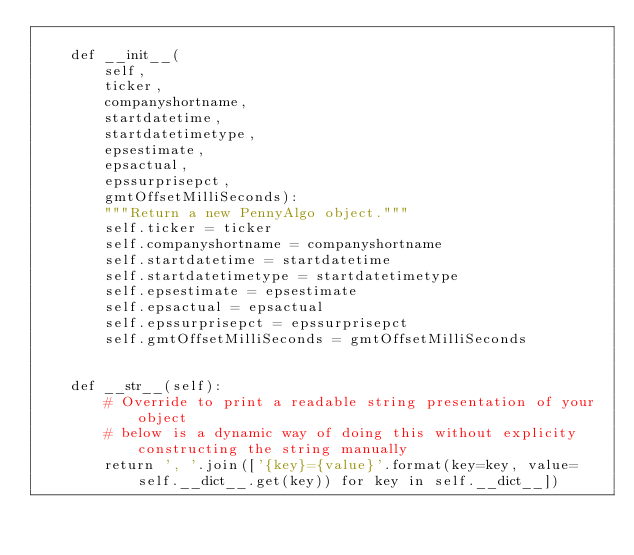<code> <loc_0><loc_0><loc_500><loc_500><_Python_>    
    def __init__(
        self, 
        ticker, 
        companyshortname, 
        startdatetime, 
        startdatetimetype,
        epsestimate,
        epsactual,
        epssurprisepct,
        gmtOffsetMilliSeconds):
        """Return a new PennyAlgo object."""
        self.ticker = ticker
        self.companyshortname = companyshortname
        self.startdatetime = startdatetime
        self.startdatetimetype = startdatetimetype
        self.epsestimate = epsestimate
        self.epsactual = epsactual
        self.epssurprisepct = epssurprisepct
        self.gmtOffsetMilliSeconds = gmtOffsetMilliSeconds


    def __str__(self):
        # Override to print a readable string presentation of your object
        # below is a dynamic way of doing this without explicity constructing the string manually
        return ', '.join(['{key}={value}'.format(key=key, value=self.__dict__.get(key)) for key in self.__dict__])

</code> 